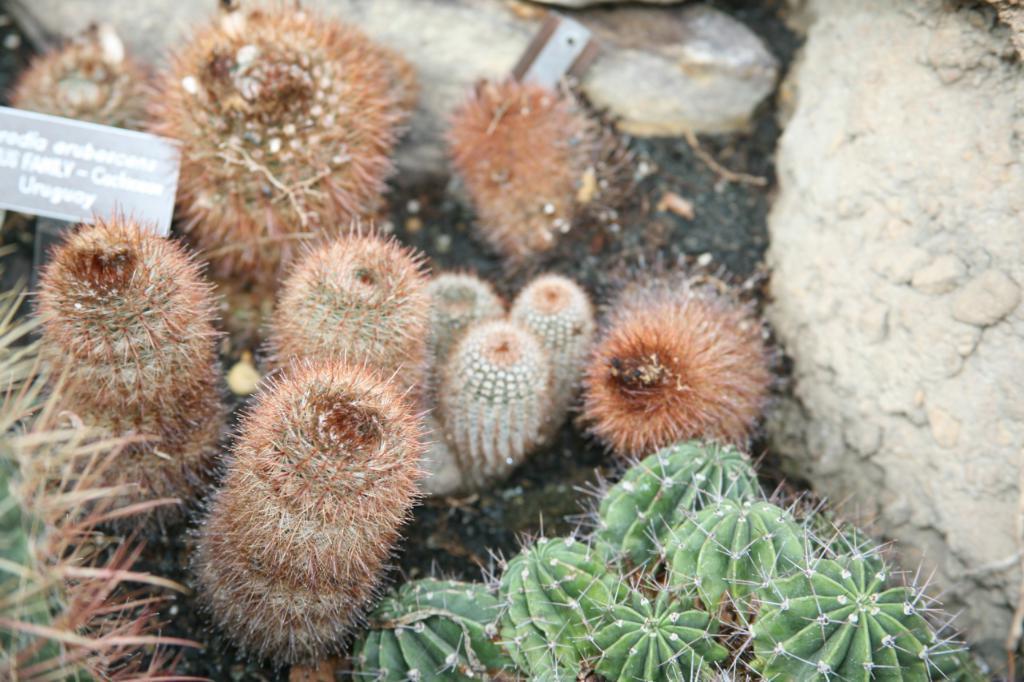In one or two sentences, can you explain what this image depicts? In this picture we can see there are cactus plants and a board. On the right side of the image, there is a rock. 